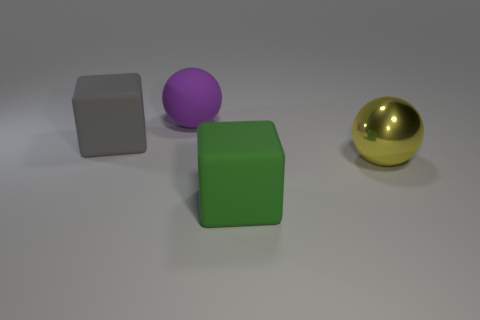Add 3 yellow spheres. How many objects exist? 7 Subtract 1 spheres. How many spheres are left? 1 Add 1 large purple things. How many large purple things are left? 2 Add 3 gray rubber cubes. How many gray rubber cubes exist? 4 Subtract 0 brown balls. How many objects are left? 4 Subtract all cyan blocks. Subtract all cyan balls. How many blocks are left? 2 Subtract all big green rubber blocks. Subtract all small red metal cylinders. How many objects are left? 3 